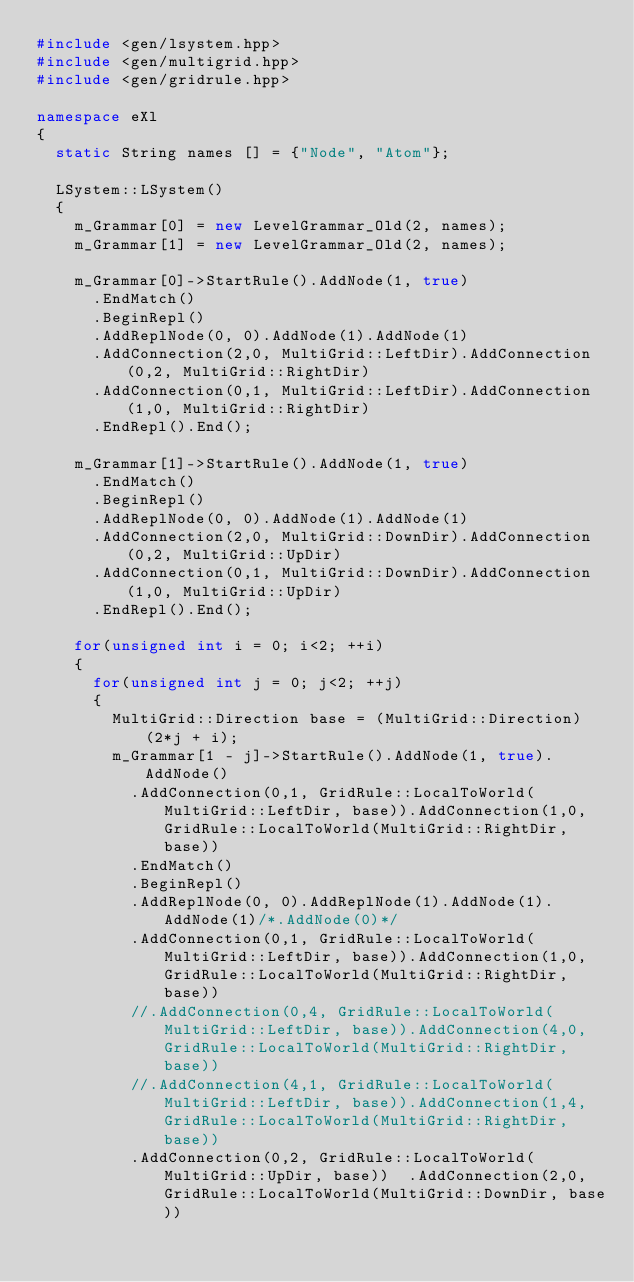Convert code to text. <code><loc_0><loc_0><loc_500><loc_500><_C++_>#include <gen/lsystem.hpp>
#include <gen/multigrid.hpp>
#include <gen/gridrule.hpp>

namespace eXl
{
  static String names [] = {"Node", "Atom"};

  LSystem::LSystem()
  {
    m_Grammar[0] = new LevelGrammar_Old(2, names);
    m_Grammar[1] = new LevelGrammar_Old(2, names);

    m_Grammar[0]->StartRule().AddNode(1, true)
      .EndMatch()
      .BeginRepl()
      .AddReplNode(0, 0).AddNode(1).AddNode(1)
      .AddConnection(2,0, MultiGrid::LeftDir).AddConnection(0,2, MultiGrid::RightDir)
      .AddConnection(0,1, MultiGrid::LeftDir).AddConnection(1,0, MultiGrid::RightDir)
      .EndRepl().End();

    m_Grammar[1]->StartRule().AddNode(1, true)
      .EndMatch()
      .BeginRepl()
      .AddReplNode(0, 0).AddNode(1).AddNode(1)
      .AddConnection(2,0, MultiGrid::DownDir).AddConnection(0,2, MultiGrid::UpDir)
      .AddConnection(0,1, MultiGrid::DownDir).AddConnection(1,0, MultiGrid::UpDir)
      .EndRepl().End();

    for(unsigned int i = 0; i<2; ++i)
    {
      for(unsigned int j = 0; j<2; ++j)
      {
        MultiGrid::Direction base = (MultiGrid::Direction)(2*j + i);
        m_Grammar[1 - j]->StartRule().AddNode(1, true).AddNode()
          .AddConnection(0,1, GridRule::LocalToWorld(MultiGrid::LeftDir, base)).AddConnection(1,0, GridRule::LocalToWorld(MultiGrid::RightDir, base))
          .EndMatch()
          .BeginRepl()
          .AddReplNode(0, 0).AddReplNode(1).AddNode(1).AddNode(1)/*.AddNode(0)*/
          .AddConnection(0,1, GridRule::LocalToWorld(MultiGrid::LeftDir, base)).AddConnection(1,0, GridRule::LocalToWorld(MultiGrid::RightDir, base))
          //.AddConnection(0,4, GridRule::LocalToWorld(MultiGrid::LeftDir, base)).AddConnection(4,0, GridRule::LocalToWorld(MultiGrid::RightDir, base))
          //.AddConnection(4,1, GridRule::LocalToWorld(MultiGrid::LeftDir, base)).AddConnection(1,4, GridRule::LocalToWorld(MultiGrid::RightDir, base))
          .AddConnection(0,2, GridRule::LocalToWorld(MultiGrid::UpDir, base))  .AddConnection(2,0, GridRule::LocalToWorld(MultiGrid::DownDir, base))</code> 